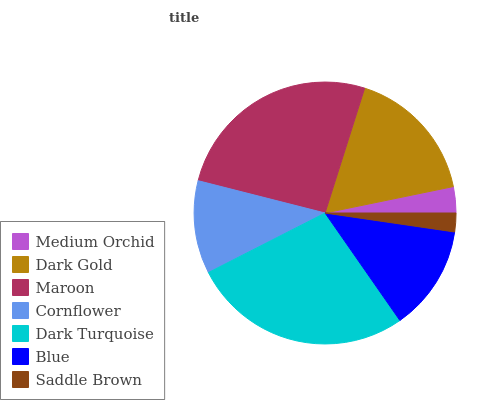Is Saddle Brown the minimum?
Answer yes or no. Yes. Is Dark Turquoise the maximum?
Answer yes or no. Yes. Is Dark Gold the minimum?
Answer yes or no. No. Is Dark Gold the maximum?
Answer yes or no. No. Is Dark Gold greater than Medium Orchid?
Answer yes or no. Yes. Is Medium Orchid less than Dark Gold?
Answer yes or no. Yes. Is Medium Orchid greater than Dark Gold?
Answer yes or no. No. Is Dark Gold less than Medium Orchid?
Answer yes or no. No. Is Blue the high median?
Answer yes or no. Yes. Is Blue the low median?
Answer yes or no. Yes. Is Saddle Brown the high median?
Answer yes or no. No. Is Dark Gold the low median?
Answer yes or no. No. 